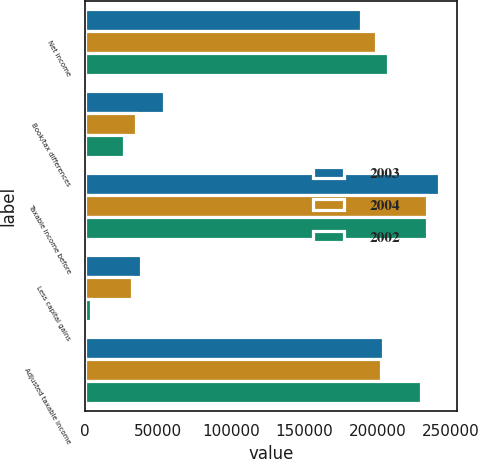Convert chart. <chart><loc_0><loc_0><loc_500><loc_500><stacked_bar_chart><ecel><fcel>Net income<fcel>Book/tax differences<fcel>Taxable income before<fcel>Less capital gains<fcel>Adjusted taxable income<nl><fcel>2003<fcel>188701<fcel>53817<fcel>242518<fcel>38655<fcel>203863<nl><fcel>2004<fcel>199232<fcel>35082<fcel>234314<fcel>32009<fcel>202305<nl><fcel>2002<fcel>207167<fcel>26856<fcel>234023<fcel>4203<fcel>229820<nl></chart> 